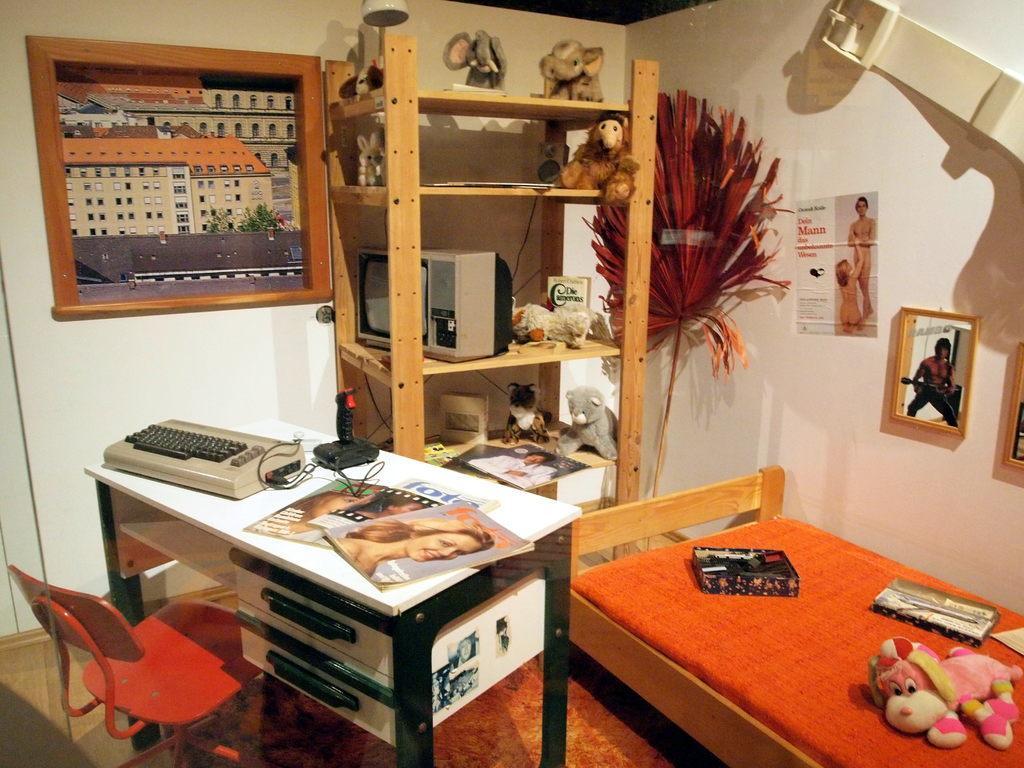Please provide a concise description of this image. In the right it's a bed and toys on it in the left it's a table and chair the middle there is a frame on the wall. 